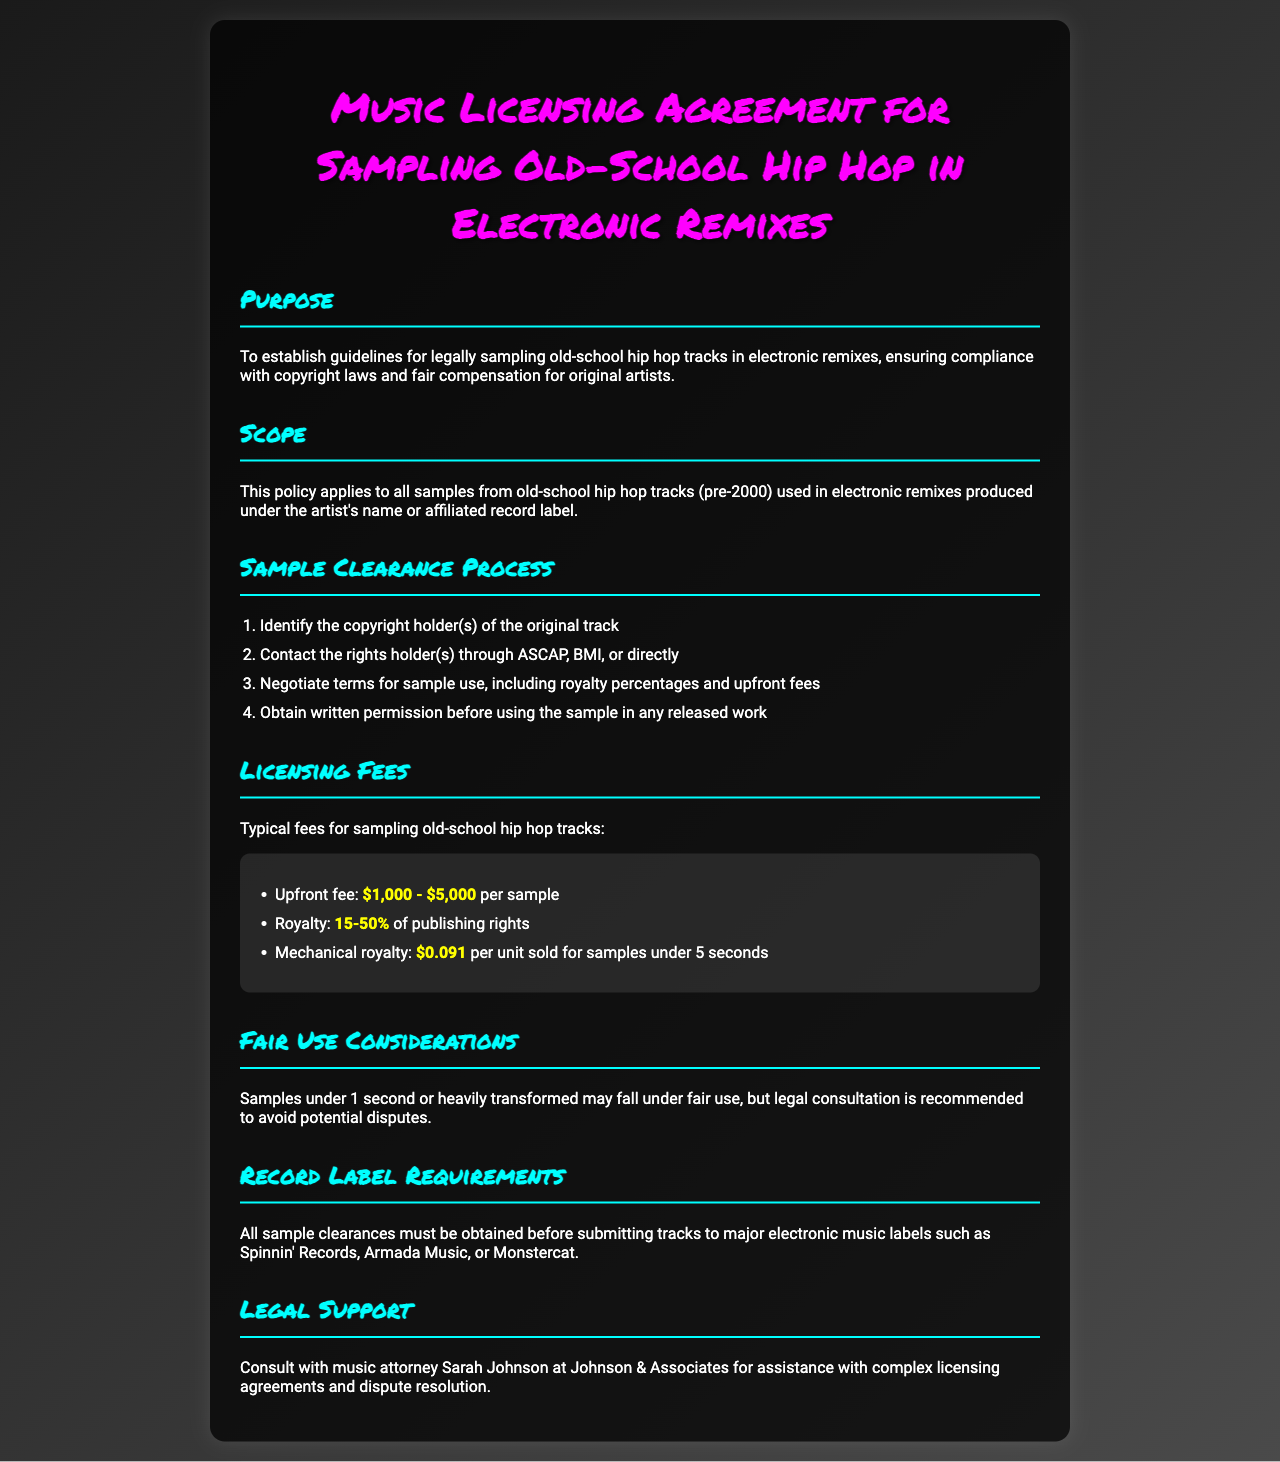What is the purpose of this agreement? The purpose is to establish guidelines for legally sampling old-school hip hop tracks in electronic remixes, ensuring compliance with copyright laws and fair compensation for original artists.
Answer: Establish guidelines for legally sampling old-school hip hop tracks Who should be contacted for sample clearance? The document states that rights holders can be contacted through ASCAP, BMI, or directly for sample clearance.
Answer: ASCAP, BMI, or directly What is the upfront fee range for sampling? The document specifies the upfront fee range for sampling old-school hip hop tracks as stated in the licensing fees section.
Answer: $1,000 - $5,000 What percentage of publishing rights is the royalty? The royalty percentage for sampling old-school hip hop tracks is provided in the licensing fees section of the document.
Answer: 15-50% What is required before submitting tracks to major labels? The document mentions that all sample clearances must be obtained before this action is taken.
Answer: Sample clearances Who is the recommended legal support mentioned? The document refers to a specific attorney for assistance with licensing agreements and disputes.
Answer: Sarah Johnson What is considered fair use regarding sample length? The document outlines the conditions under which fair use may apply, particularly related to sample duration.
Answer: Under 1 second What type of tracks does this policy apply to? The scope section of the document indicates the category of tracks this policy covers.
Answer: Old-school hip hop tracks (pre-2000) 